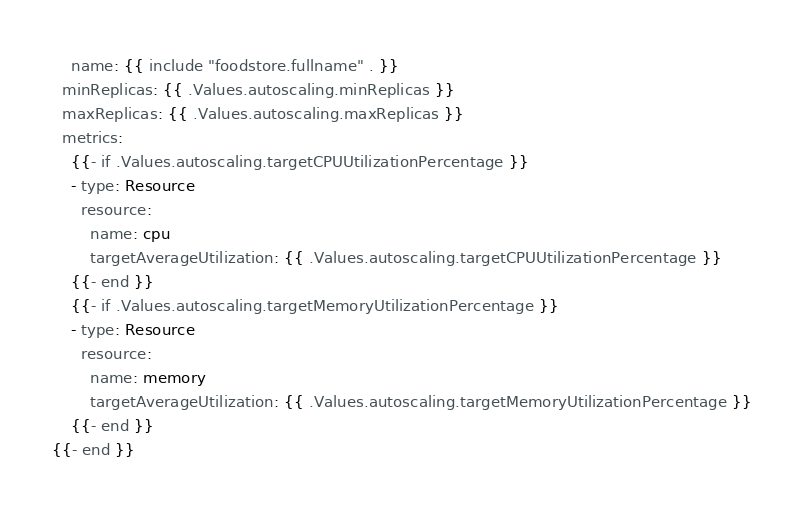<code> <loc_0><loc_0><loc_500><loc_500><_YAML_>    name: {{ include "foodstore.fullname" . }}
  minReplicas: {{ .Values.autoscaling.minReplicas }}
  maxReplicas: {{ .Values.autoscaling.maxReplicas }}
  metrics:
    {{- if .Values.autoscaling.targetCPUUtilizationPercentage }}
    - type: Resource
      resource:
        name: cpu
        targetAverageUtilization: {{ .Values.autoscaling.targetCPUUtilizationPercentage }}
    {{- end }}
    {{- if .Values.autoscaling.targetMemoryUtilizationPercentage }}
    - type: Resource
      resource:
        name: memory
        targetAverageUtilization: {{ .Values.autoscaling.targetMemoryUtilizationPercentage }}
    {{- end }}
{{- end }}
</code> 